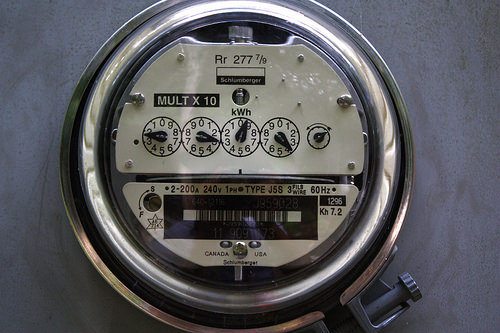<image>
Is the glass on the bezel? Yes. Looking at the image, I can see the glass is positioned on top of the bezel, with the bezel providing support. Is there a glass behind the dial? No. The glass is not behind the dial. From this viewpoint, the glass appears to be positioned elsewhere in the scene. 